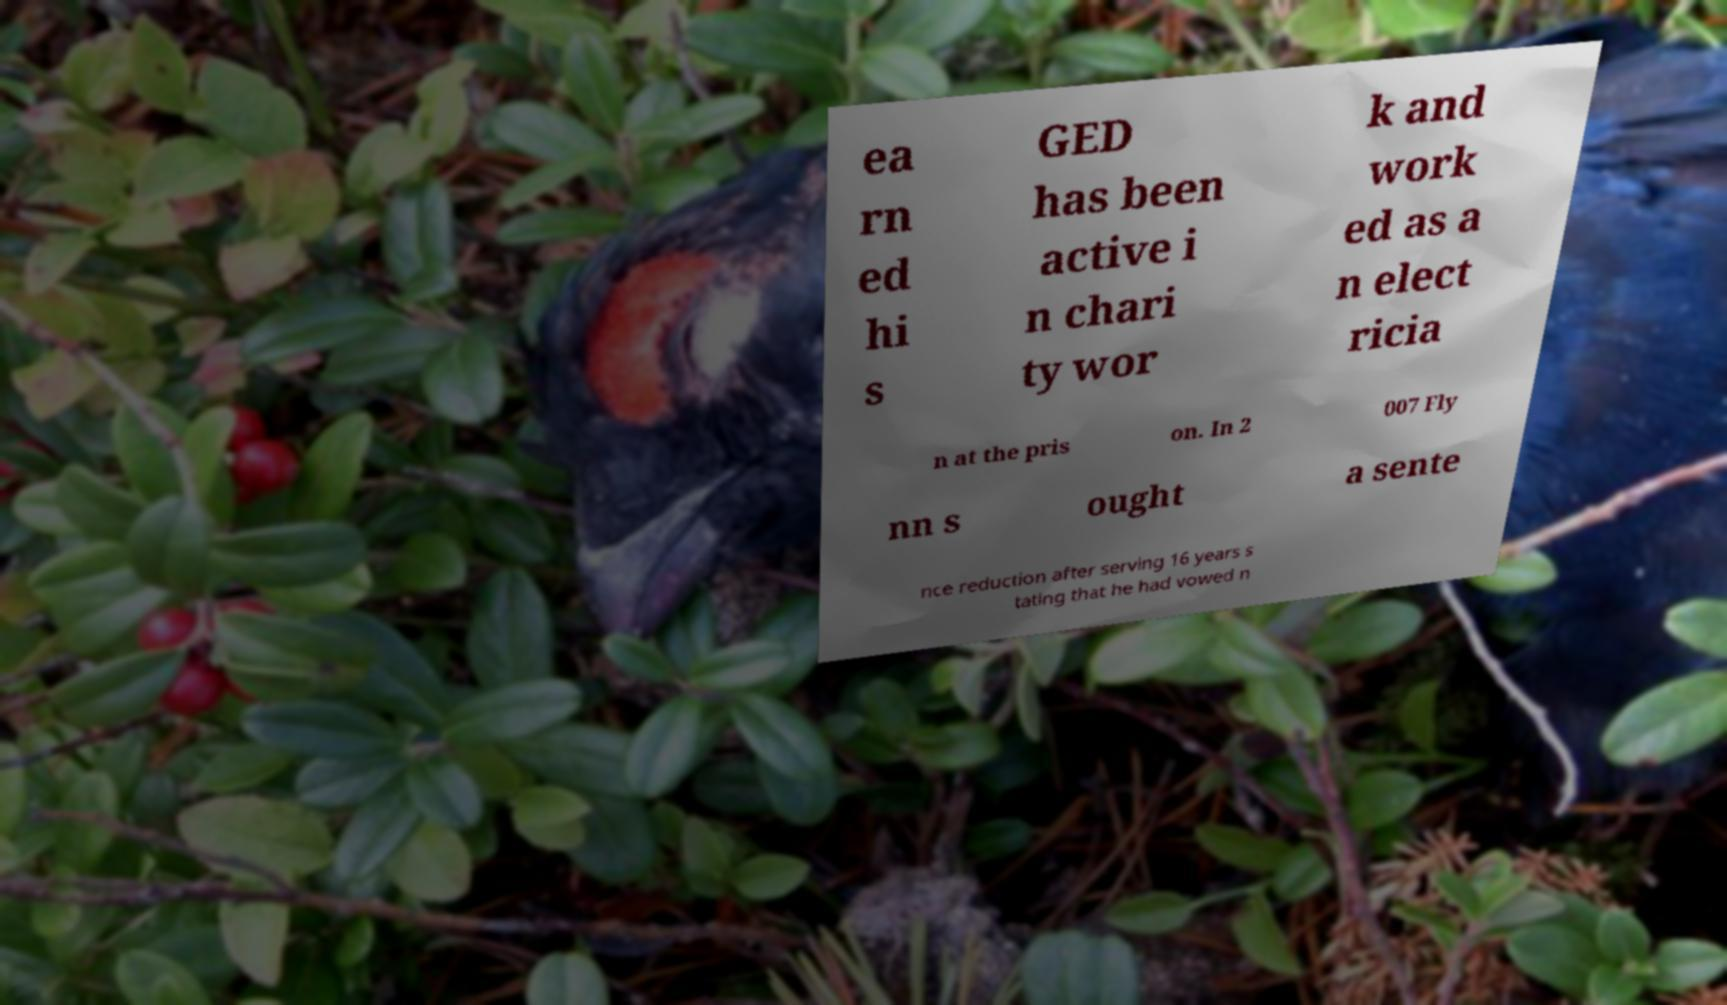For documentation purposes, I need the text within this image transcribed. Could you provide that? ea rn ed hi s GED has been active i n chari ty wor k and work ed as a n elect ricia n at the pris on. In 2 007 Fly nn s ought a sente nce reduction after serving 16 years s tating that he had vowed n 